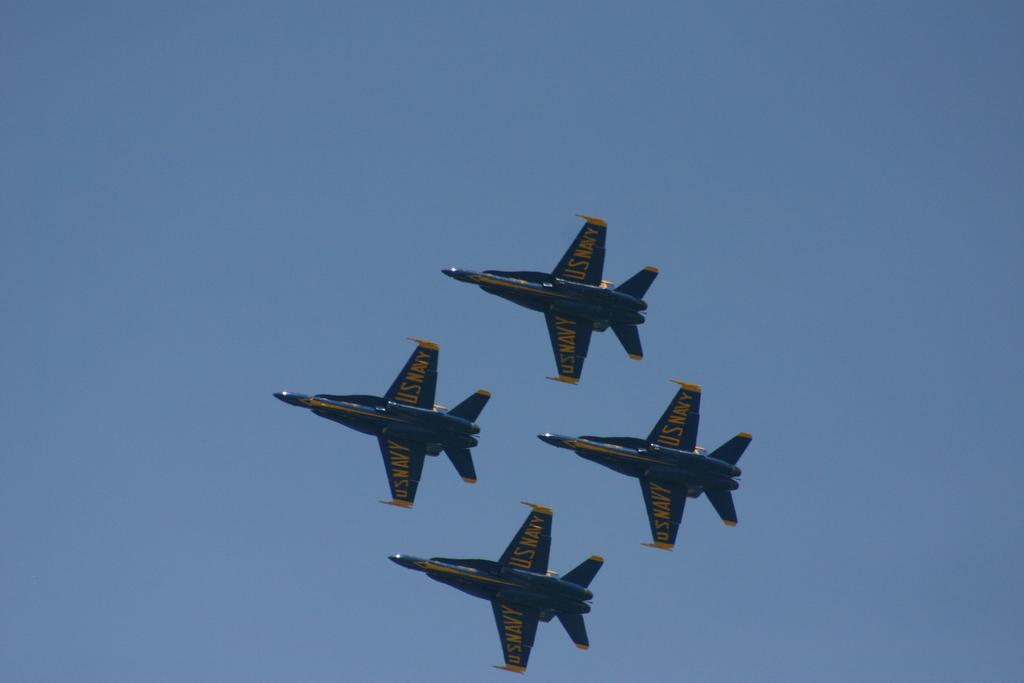How many aircrafts are present in the image? There are four aircrafts in the image. What are the aircrafts doing in the image? The aircrafts are flying in the sky. Is there any text visible on the aircrafts? Yes, there is some text visible on the aircrafts. What type of polish is being applied to the aircrafts in the image? There is no polish being applied to the aircrafts in the image; they are simply flying in the sky. 